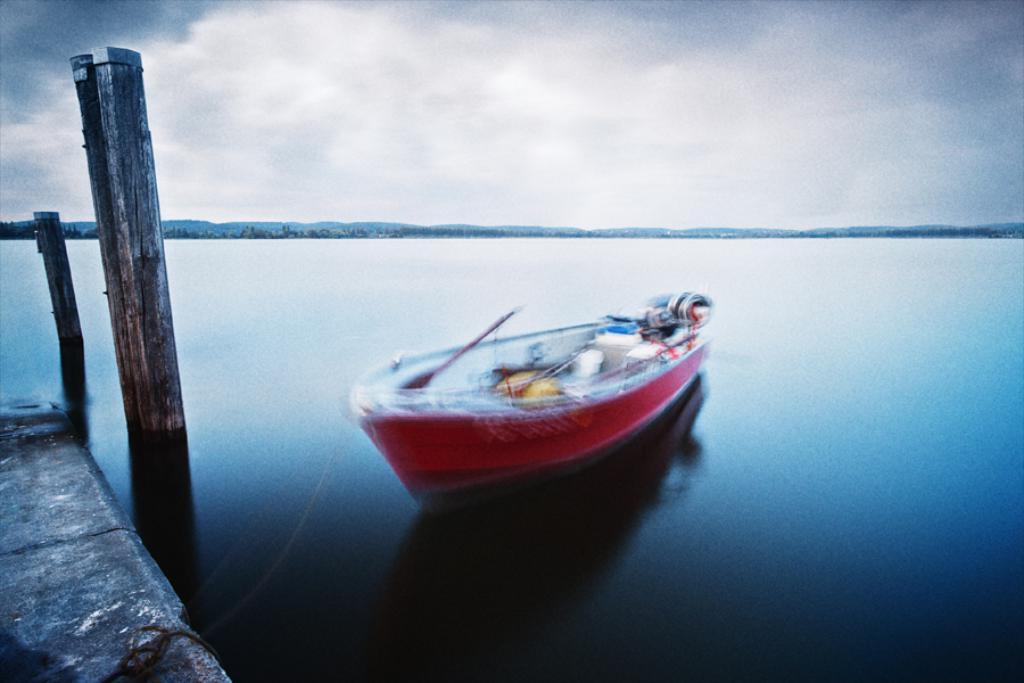Could you give a brief overview of what you see in this image? In this image I can see a boat is in the water, it is in red color. At the top it is the cloudy sky. On the left side there are wooden logs. 